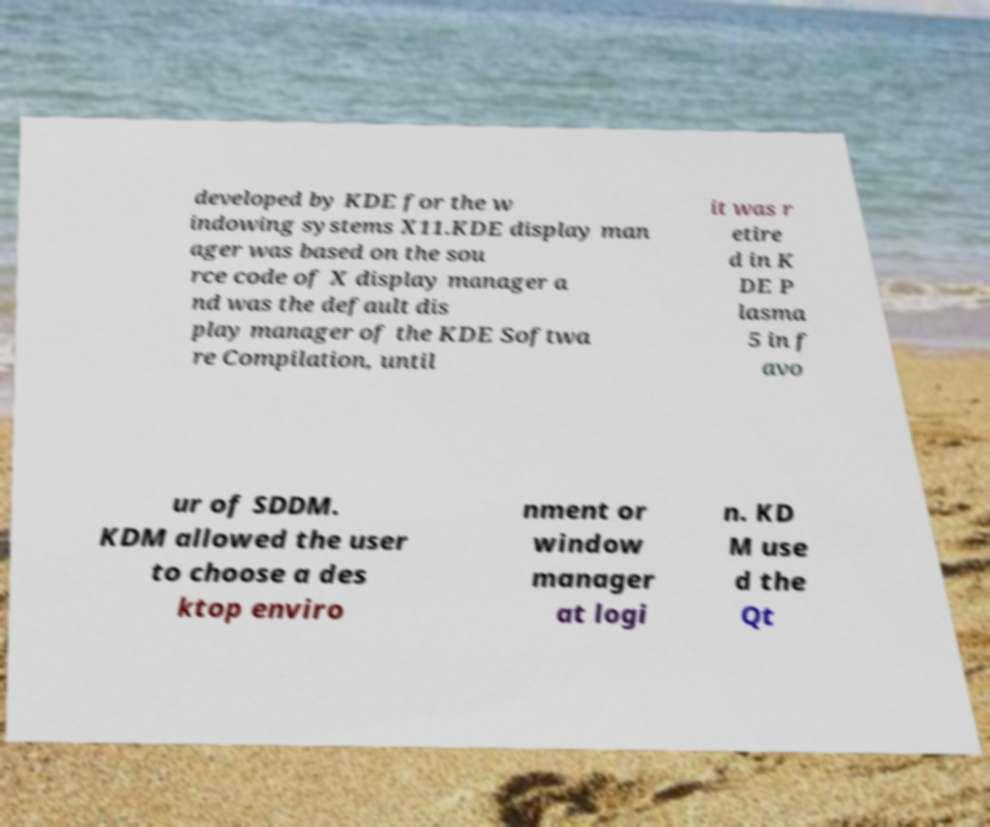There's text embedded in this image that I need extracted. Can you transcribe it verbatim? developed by KDE for the w indowing systems X11.KDE display man ager was based on the sou rce code of X display manager a nd was the default dis play manager of the KDE Softwa re Compilation, until it was r etire d in K DE P lasma 5 in f avo ur of SDDM. KDM allowed the user to choose a des ktop enviro nment or window manager at logi n. KD M use d the Qt 